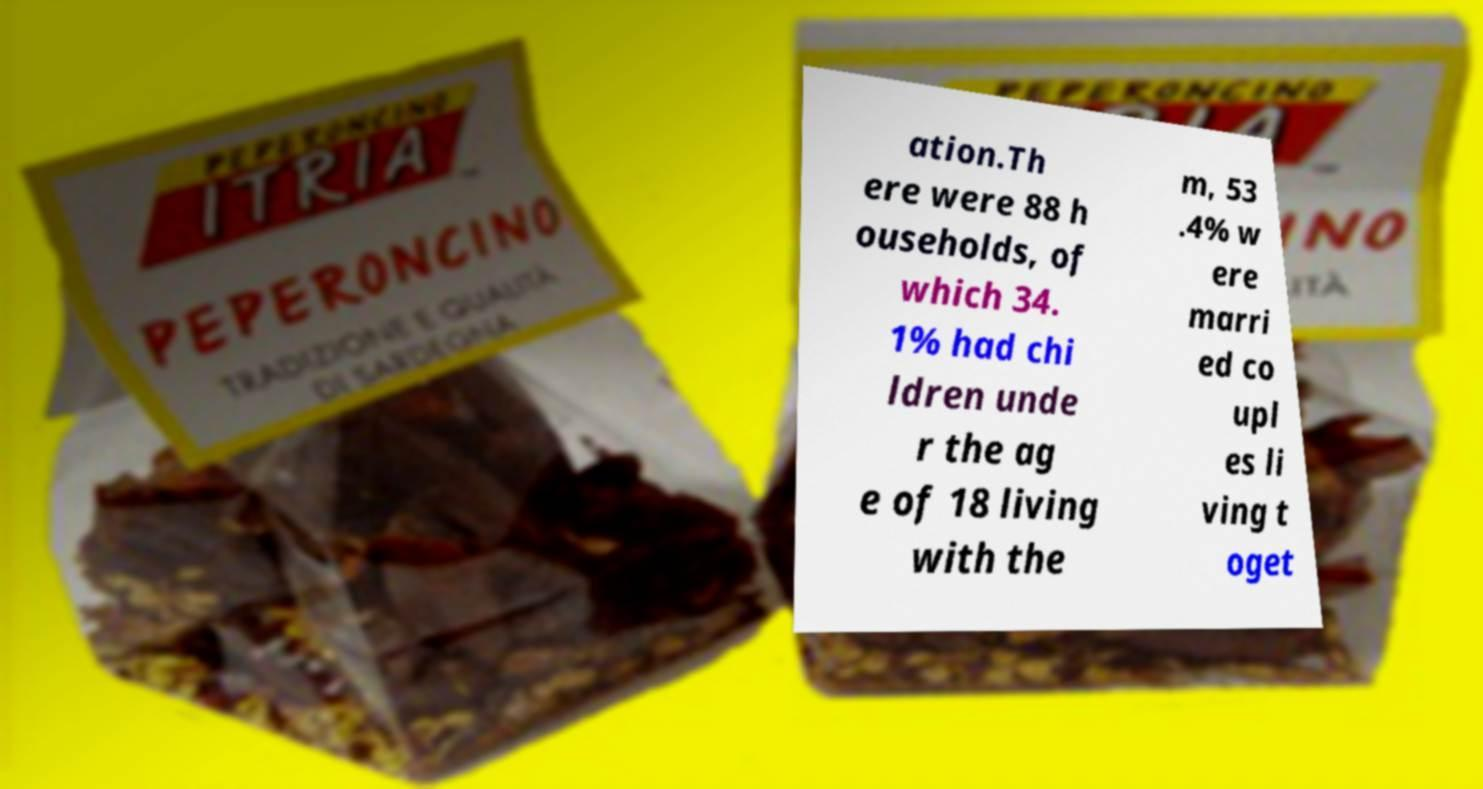Can you accurately transcribe the text from the provided image for me? ation.Th ere were 88 h ouseholds, of which 34. 1% had chi ldren unde r the ag e of 18 living with the m, 53 .4% w ere marri ed co upl es li ving t oget 